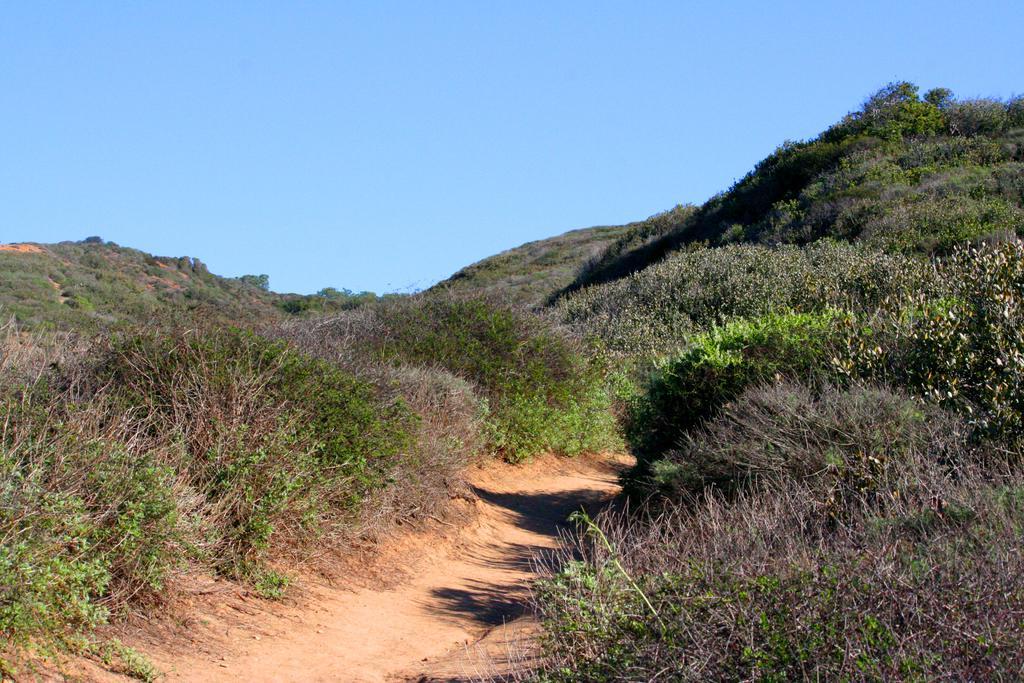Describe this image in one or two sentences. In this picture we can see few plants, trees and hills. 